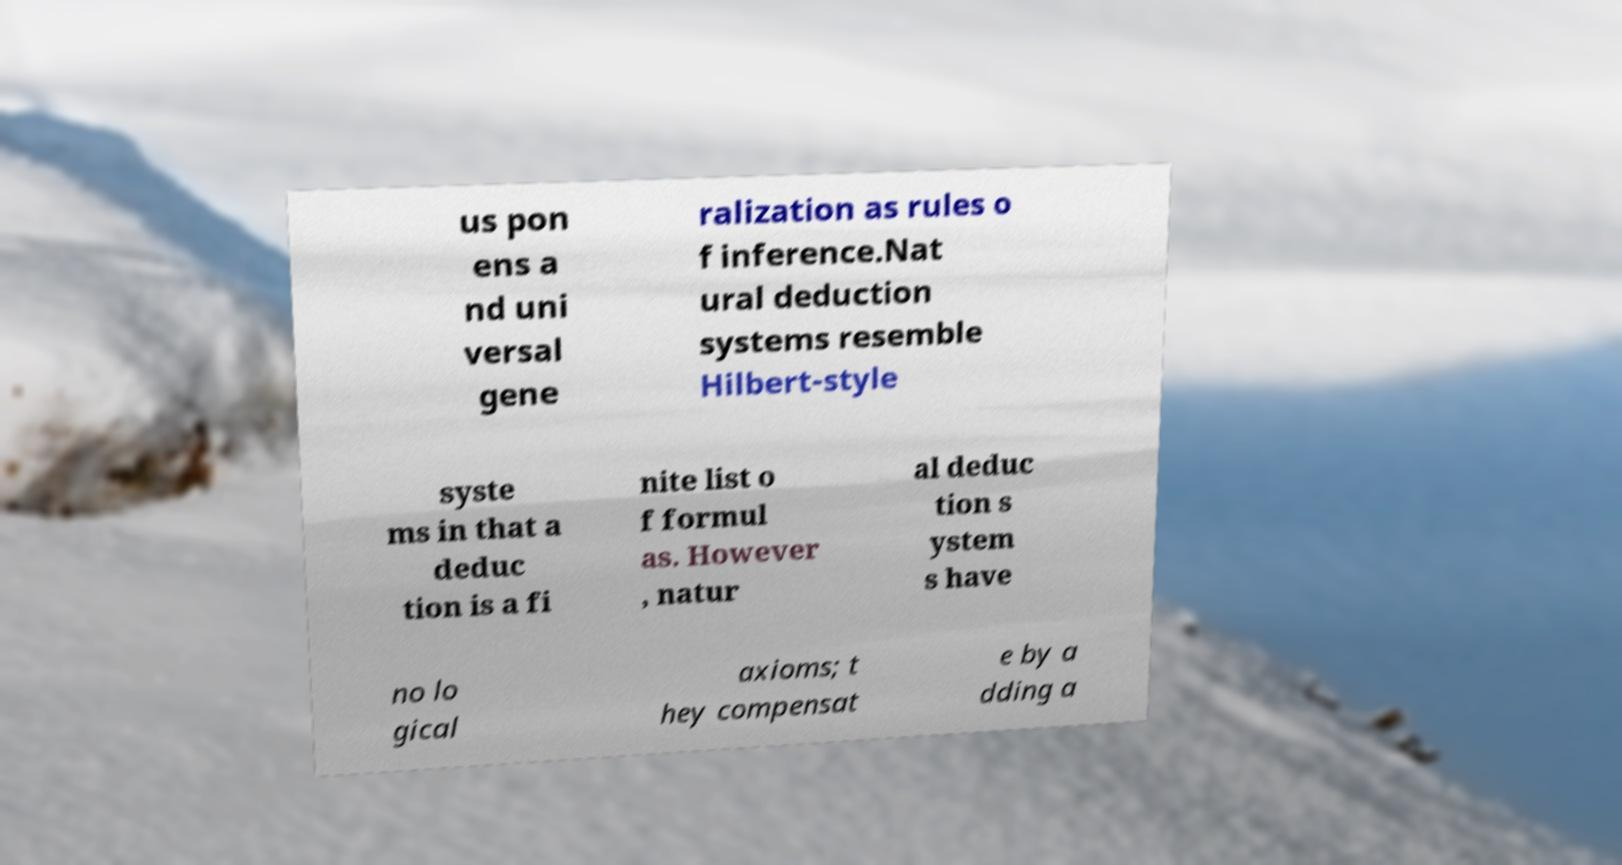Could you extract and type out the text from this image? us pon ens a nd uni versal gene ralization as rules o f inference.Nat ural deduction systems resemble Hilbert-style syste ms in that a deduc tion is a fi nite list o f formul as. However , natur al deduc tion s ystem s have no lo gical axioms; t hey compensat e by a dding a 